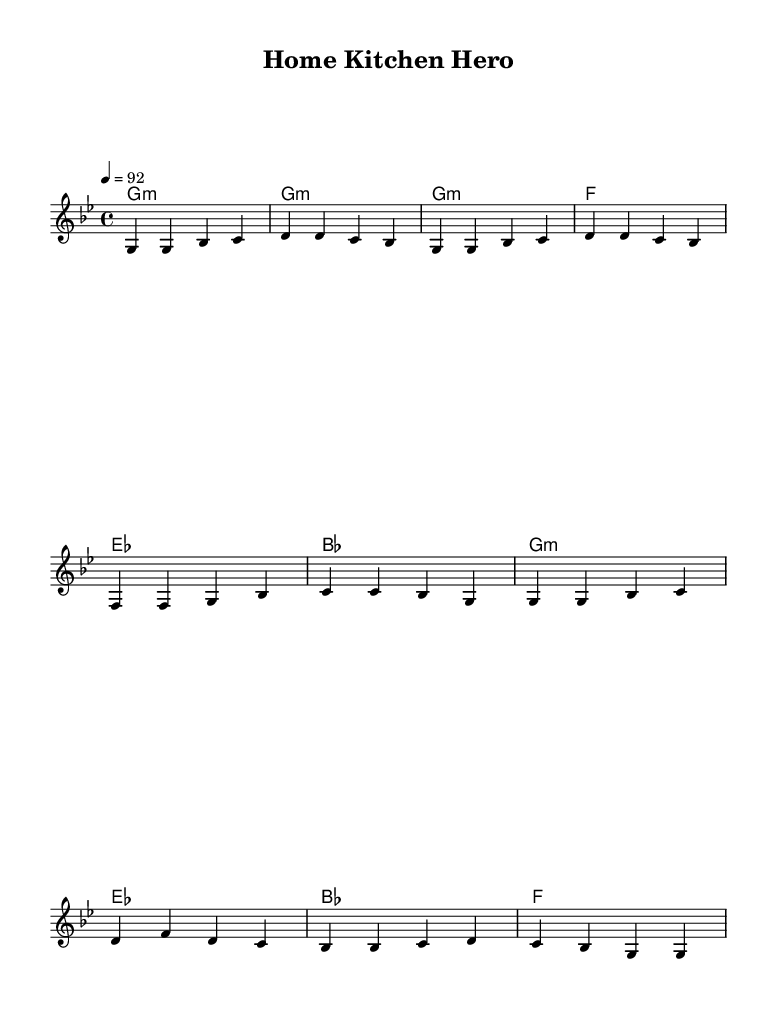What is the key signature of this music? The key signature is B flat major, indicated by the presence of two flat symbols on the staff.
Answer: B flat major What is the time signature of this music? The time signature is 4/4, represented by the "4" on top and "4" on the bottom, indicating four beats per measure and a quarter note receives one beat.
Answer: 4/4 What is the tempo marking of this piece? The tempo marking is 92 beats per minute, specified in the score, which dictates the speed at which the piece should be played.
Answer: 92 Which musical section follows the verse? The section that follows the verse is the chorus as indicated in the structure of the song where the chorus usually comes after the verse.
Answer: Chorus How many measures does the intro contain? The intro contains two measures, as counted from the beginning of the melody before transitioning into the verse.
Answer: 2 What type of musical piece is this? This piece is a hip hop anthem, which is identified by its specific lyrical content and rhythm structure designed to praise stay-at-home parents and their cooking.
Answer: Hip hop anthem What is the main theme expressed in the lyrics? The main theme expressed in the lyrics is the appreciation of stay-at-home parents and their culinary skills, celebrating their contributions in a light-hearted manner.
Answer: Culinary skills 